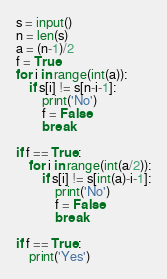Convert code to text. <code><loc_0><loc_0><loc_500><loc_500><_Python_>s = input()
n = len(s)
a = (n-1)/2
f = True
for i in range(int(a)):
    if s[i] != s[n-i-1]:
        print('No')
        f = False
        break
        
if f == True:
    for i in range(int(a/2)):
        if s[i] != s[int(a)-i-1]:
            print('No')
            f = False
            break
            
if f == True:
    print('Yes')</code> 